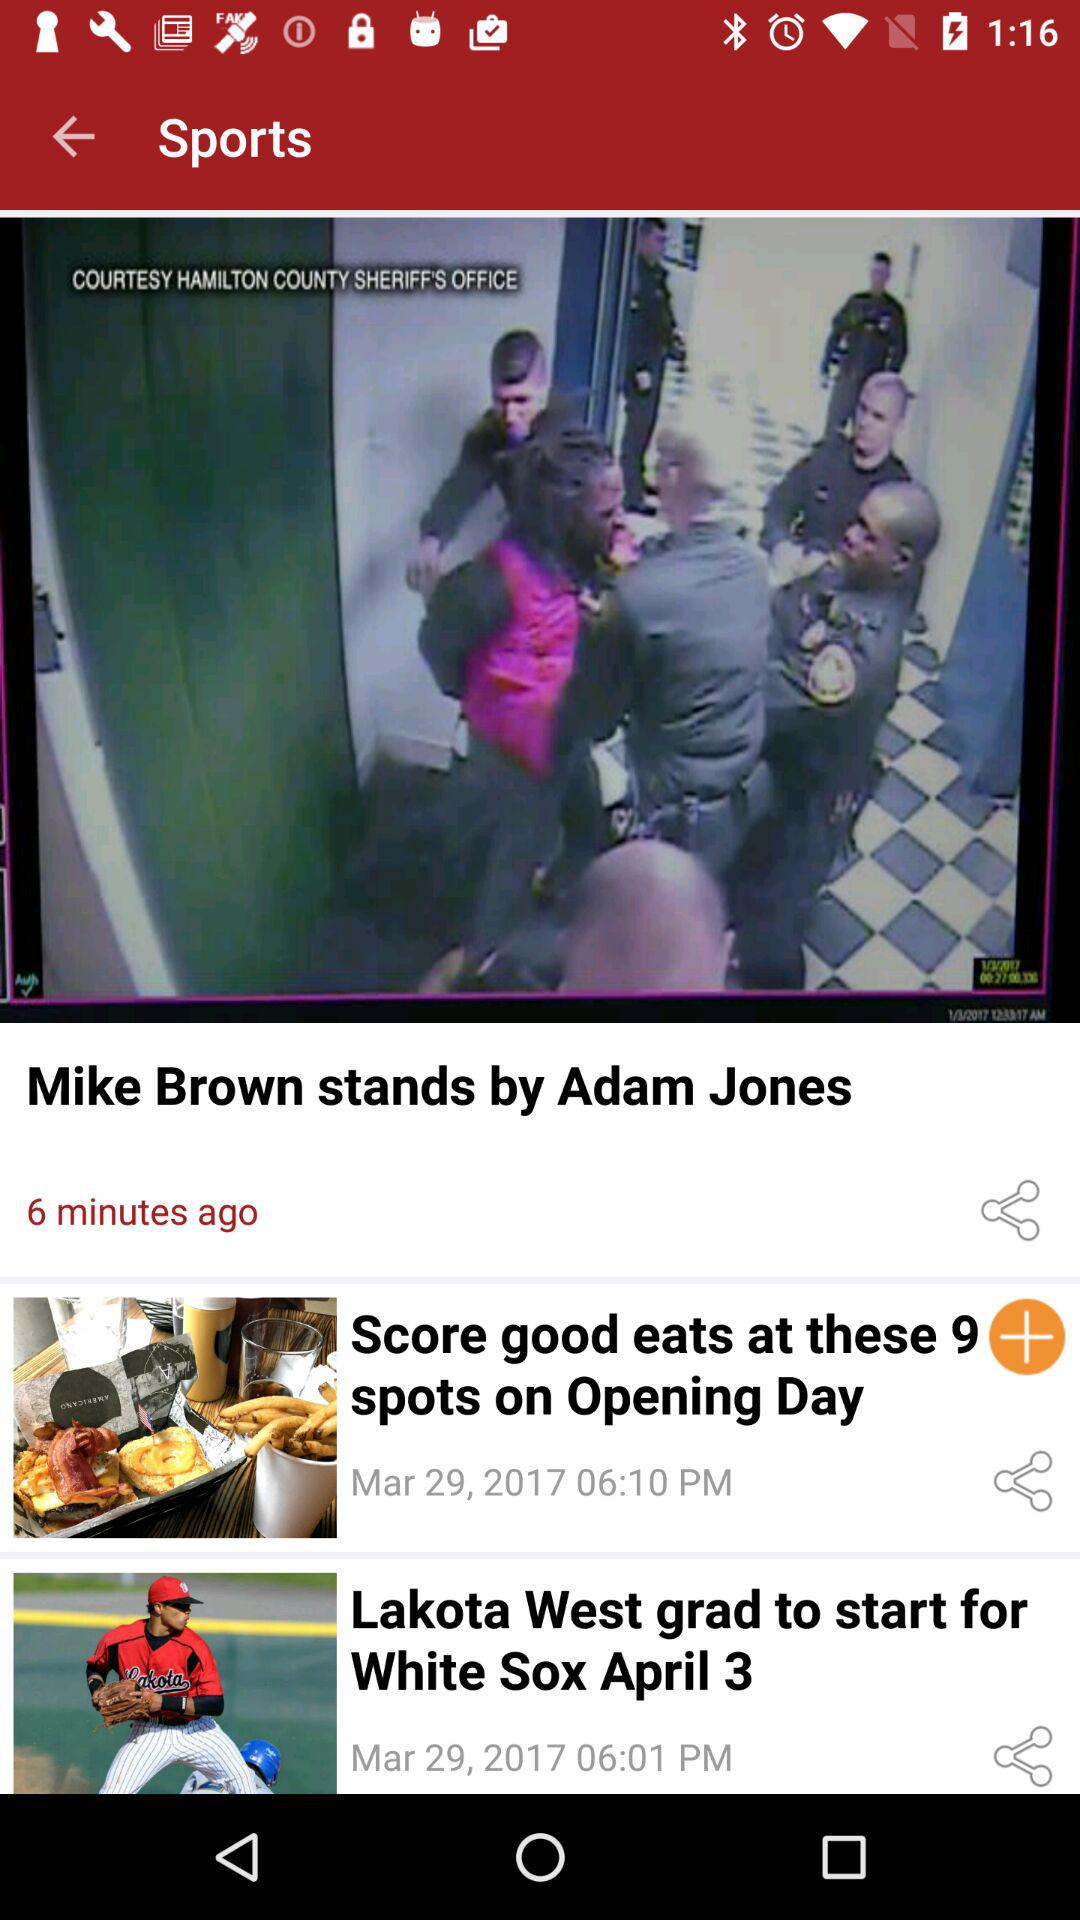What is the date of the "Lakota West grad to start for White Sox April 3" article? The date is March 29, 2017. 